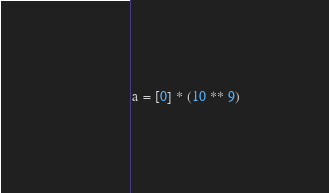Convert code to text. <code><loc_0><loc_0><loc_500><loc_500><_Python_>a = [0] * (10 ** 9)</code> 